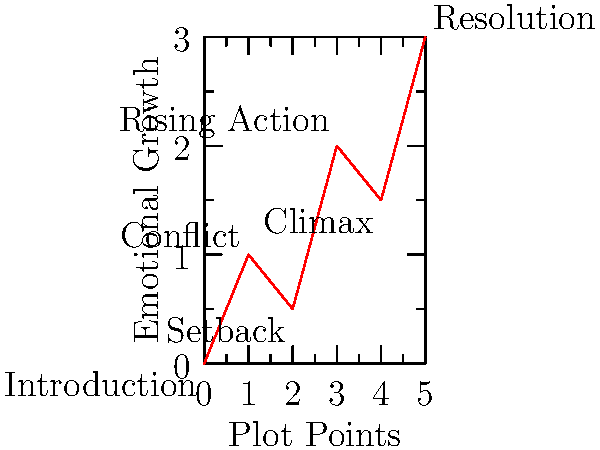Analyzing the character development arc depicted in the line graph, which plot point represents the moment of greatest emotional growth for the protagonist, and how might this inform your approach to crafting memorable characters in your novels? To answer this question, let's analyze the graph step-by-step:

1. The x-axis represents plot points, while the y-axis shows emotional growth.
2. We can see six key points in the character's journey:
   - Introduction (0,0)
   - Conflict (1,1)
   - Setback (2,0.5)
   - Rising Action (3,2)
   - Climax (4,1.5)
   - Resolution (5,3)

3. To determine the point of greatest emotional growth, we need to look at the steepest positive slope between two consecutive points.

4. The steepest positive slope occurs between the Climax (4,1.5) and Resolution (5,3) points.

5. This indicates that the character experiences the most significant emotional growth between these two plot points.

6. As a novelist, this insight can inform character development by:
   - Emphasizing the importance of the resolution phase in character arcs
   - Showing how overcoming the climax can lead to substantial personal growth
   - Demonstrating that the most profound character changes can occur after the main conflict is resolved

7. To craft memorable characters, consider:
   - Building tension throughout the story to maximize the impact of the final growth
   - Ensuring that earlier setbacks and conflicts contribute to the character's ability to grow at the end
   - Focusing on the internal transformation that occurs as a result of the external events in the plot

By understanding this pattern of growth, you can create more dynamic and compelling character arcs in your novels, similar to how screenwriters craft memorable characters for the screen.
Answer: Resolution; emphasize post-climax growth for memorable character development. 